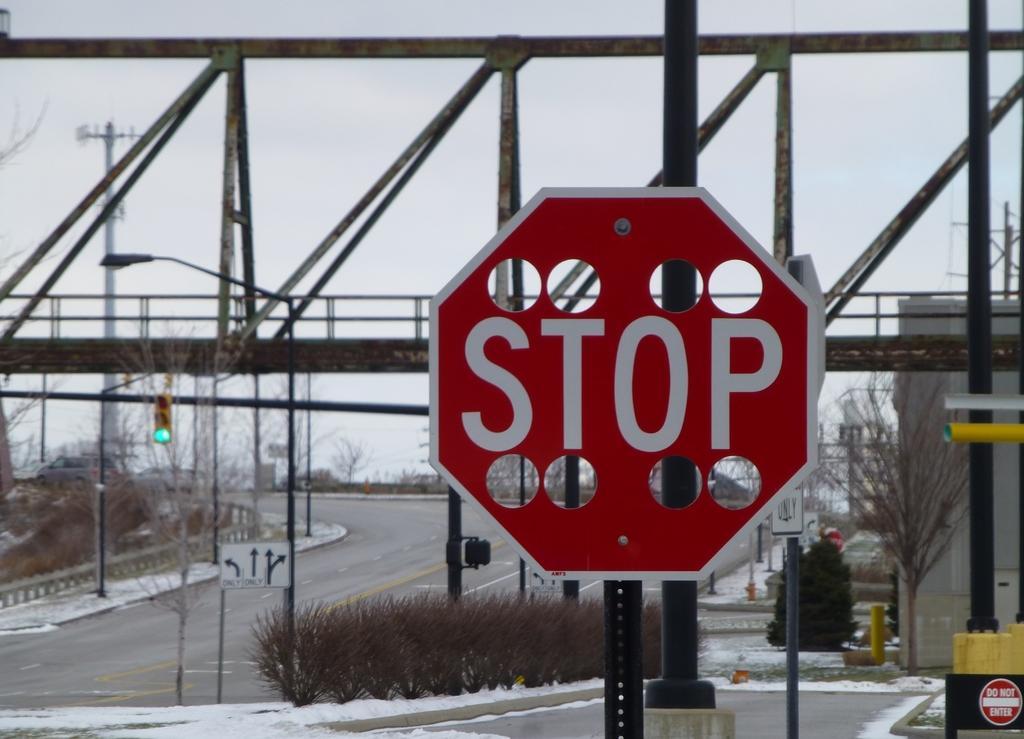Please provide a concise description of this image. In this image in the front there is a board with some text written on it. In the center there is a bridged, there are poles, plants. In the background there are trees. 